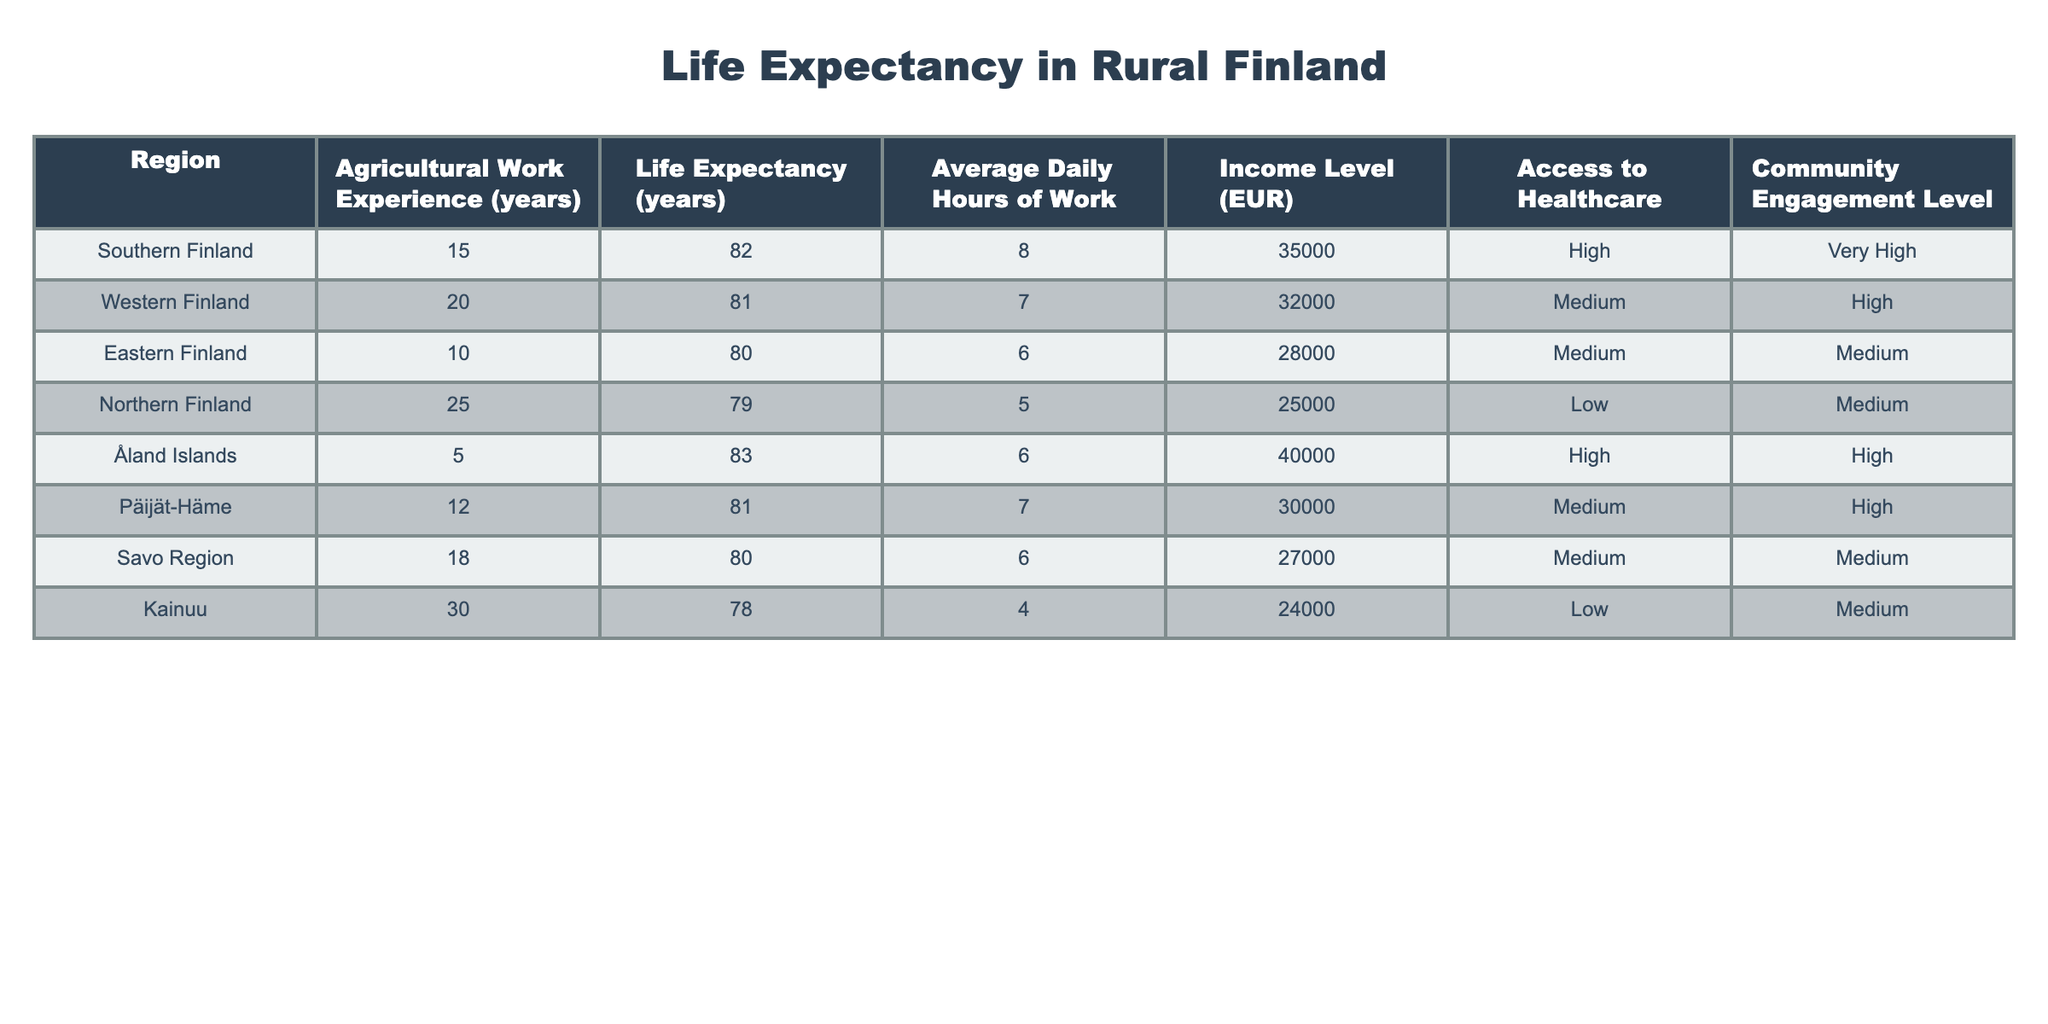What is the life expectancy in Southern Finland? Southern Finland's life expectancy is listed directly in the table under the specific region. Referring to the table, it shows that the life expectancy for Southern Finland is 82 years.
Answer: 82 Which region has the highest life expectancy? By examining the life expectancy values in the table, Åland Islands shows the highest value at 83 years, which is greater than all other regions listed.
Answer: 83 How many years of agricultural work experience does Northern Finland indicate? The table presents Northern Finland with an agricultural work experience of 25 years. This is a simple retrieval from the respective row in the table.
Answer: 25 Is the income level in Kainuu higher than in Northern Finland? Kainuu has an income level of 24,000 EUR and Northern Finland has 25,000 EUR. Thus, by comparing these two income levels, we find that Kainuu's income is lower than Northern Finland's.
Answer: No What is the average life expectancy of regions with more than 15 years of agricultural work experience? The regions with more than 15 years of agricultural work experience are Northern Finland (79 years), Kainuu (78 years), and Western Finland (81 years). The average is calculated by adding these values (79 + 78 + 81) = 238 and dividing by 3 (238/3 = 79.33).
Answer: 79.33 Does higher community engagement correlate with higher life expectancy in the data? By analyzing the table, we find that both Southern Finland and Åland Islands have high community engagement and higher life expectancies (82 and 83 years, respectively). However, Western Finland also has high community engagement but a slightly lower life expectancy at 81 years. Therefore, the correlation is not definitive based on this data alone.
Answer: No What is the difference in life expectancy between regions with high access to healthcare and those with low access? Regions with high access to healthcare are Southern Finland (82 years), Åland Islands (83 years), and Päijät-Häme (81 years), making the average for high access 82 years. For low access, Northern Finland is at 79 years and Kainuu at 78 years, resulting in an average of 78.5 years for low access. Thus, the difference between the two averages is 82 - 78.5 = 3.5 years.
Answer: 3.5 Which region has the lowest average daily hours of work? By checking the table, Kainuu has the lowest average daily hours of work listed at 4 hours per day. This is a straightforward retrieval of the specific value from the table.
Answer: 4 What is the total income level of the two regions with the least agricultural work experience? The two regions with the least agricultural work experience are Åland Islands (5 years, 40,000 EUR) and Eastern Finland (10 years, 28,000 EUR). Adding their income levels together gives 40,000 + 28,000 = 68,000 EUR.
Answer: 68000 